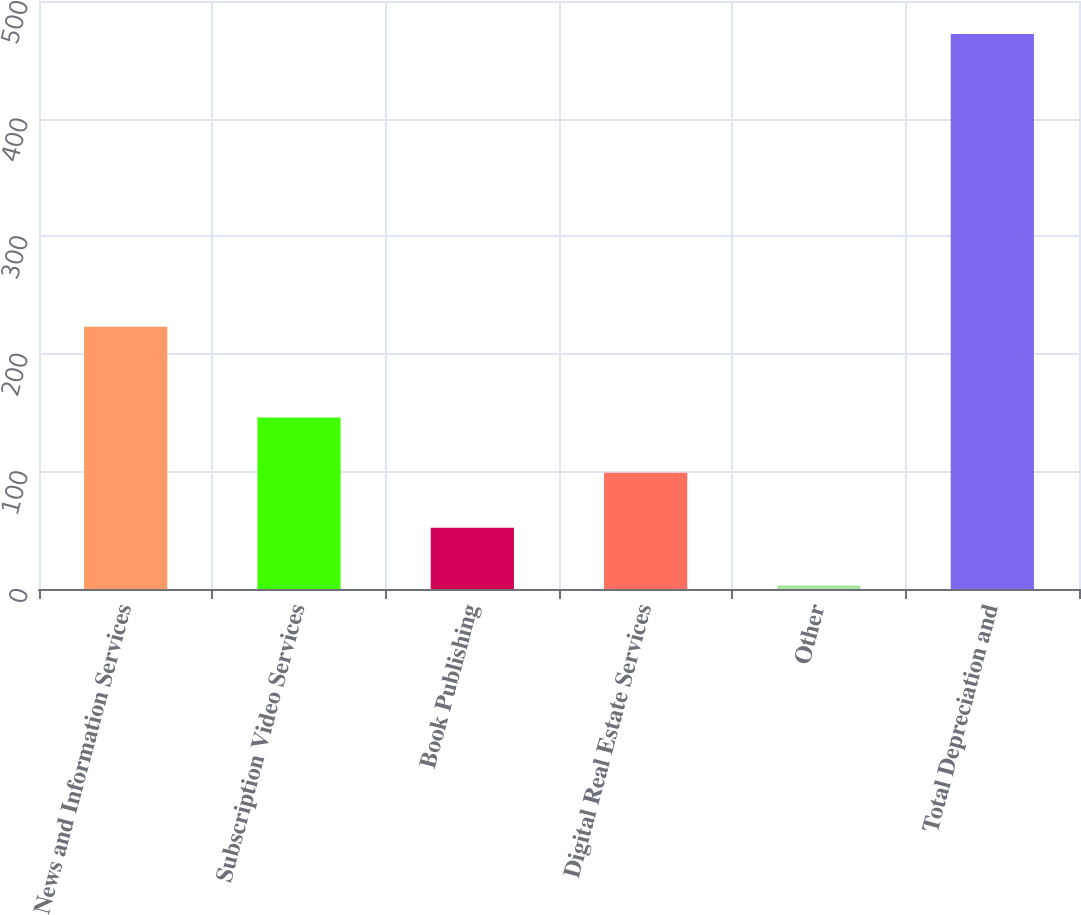<chart> <loc_0><loc_0><loc_500><loc_500><bar_chart><fcel>News and Information Services<fcel>Subscription Video Services<fcel>Book Publishing<fcel>Digital Real Estate Services<fcel>Other<fcel>Total Depreciation and<nl><fcel>223<fcel>145.8<fcel>52<fcel>98.9<fcel>3<fcel>472<nl></chart> 